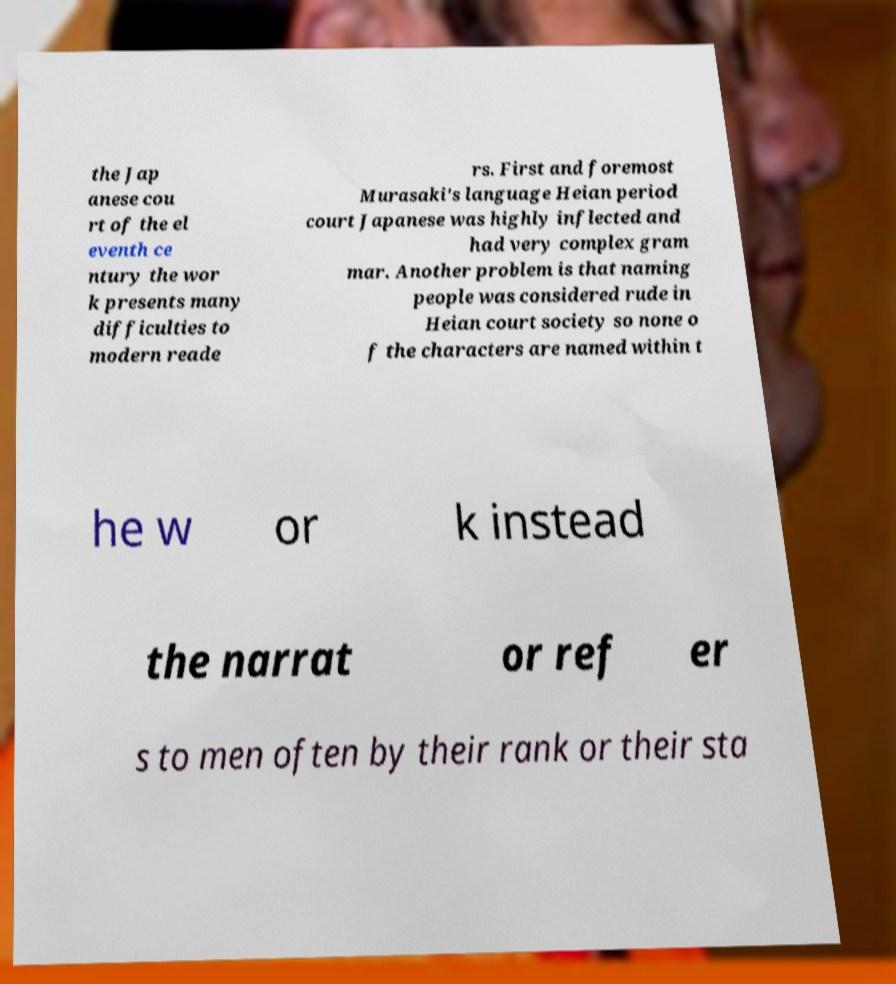Can you accurately transcribe the text from the provided image for me? the Jap anese cou rt of the el eventh ce ntury the wor k presents many difficulties to modern reade rs. First and foremost Murasaki's language Heian period court Japanese was highly inflected and had very complex gram mar. Another problem is that naming people was considered rude in Heian court society so none o f the characters are named within t he w or k instead the narrat or ref er s to men often by their rank or their sta 